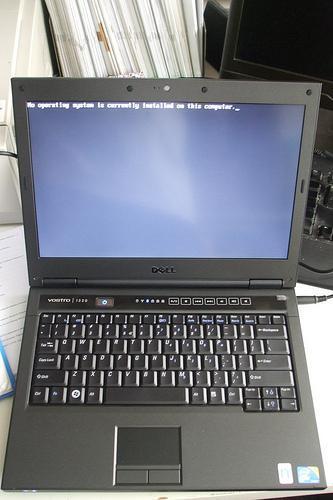How many people are typing computer?
Give a very brief answer. 0. 